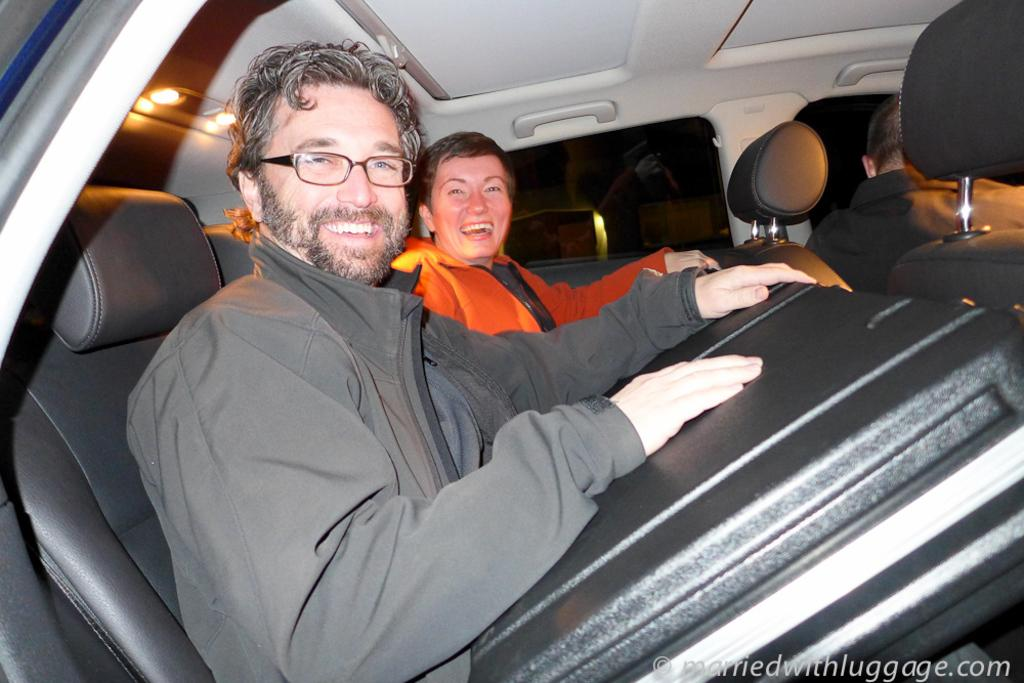What are the people in the image wearing? One person is wearing an orange shirt, and the other is wearing a gray coat. What is the facial expression of the people in the image? Both people in the image are smiling. Where are the people in the image sitting? They are sitting on the seat of a vehicle. What is the color of the background in the image? The background of the image is dark. What type of liquid can be seen dripping from the ceiling in the image? There is no liquid or dripping ceiling present in the image. Is there a cellar visible in the image? No, there is no cellar present in the image. 